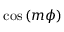<formula> <loc_0><loc_0><loc_500><loc_500>\cos \left ( m \phi \right )</formula> 